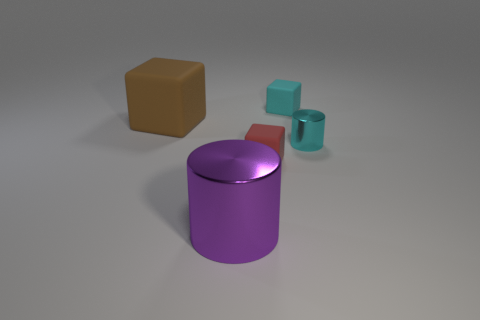There is a object that is the same color as the tiny metallic cylinder; what size is it?
Provide a short and direct response. Small. There is a cube to the left of the small red object; what is its material?
Your response must be concise. Rubber. What is the material of the brown cube?
Give a very brief answer. Rubber. Do the cyan thing that is behind the cyan shiny object and the small cylinder have the same material?
Give a very brief answer. No. Are there fewer brown matte objects that are on the left side of the large brown cube than tiny gray metal blocks?
Offer a very short reply. No. What is the color of the metallic cylinder that is the same size as the cyan matte thing?
Offer a very short reply. Cyan. How many brown things are the same shape as the tiny red thing?
Give a very brief answer. 1. There is a metallic cylinder on the right side of the big cylinder; what color is it?
Provide a succinct answer. Cyan. What number of matte objects are either cyan objects or large objects?
Ensure brevity in your answer.  2. What shape is the matte object that is the same color as the tiny metallic object?
Your answer should be very brief. Cube. 